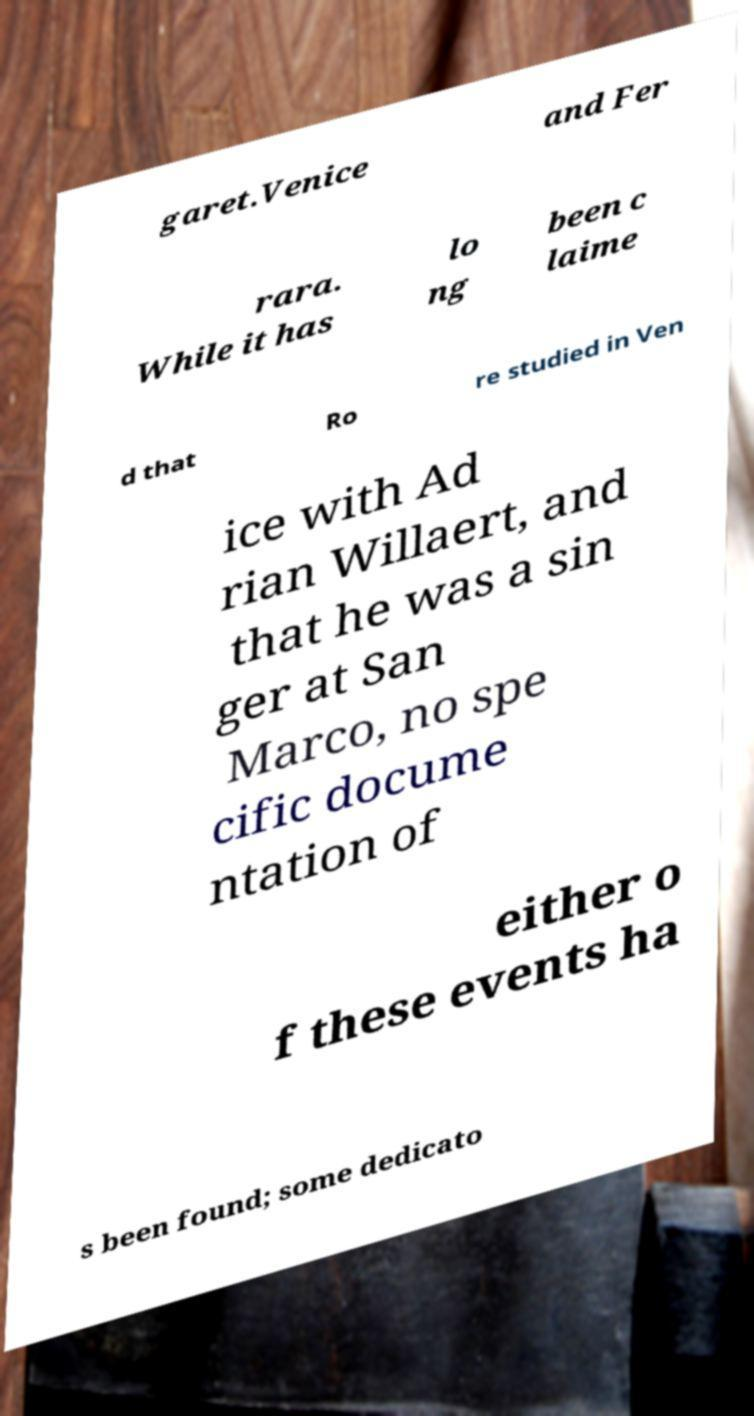I need the written content from this picture converted into text. Can you do that? garet.Venice and Fer rara. While it has lo ng been c laime d that Ro re studied in Ven ice with Ad rian Willaert, and that he was a sin ger at San Marco, no spe cific docume ntation of either o f these events ha s been found; some dedicato 